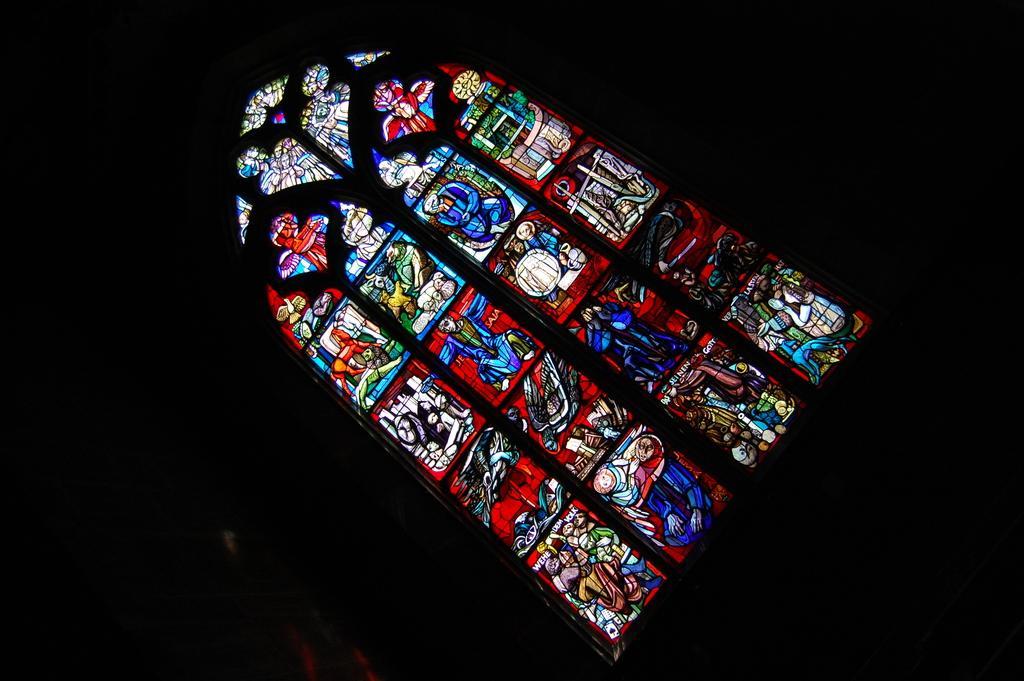Please provide a concise description of this image. This picture is dark, in this picture we can see painting on glass. 